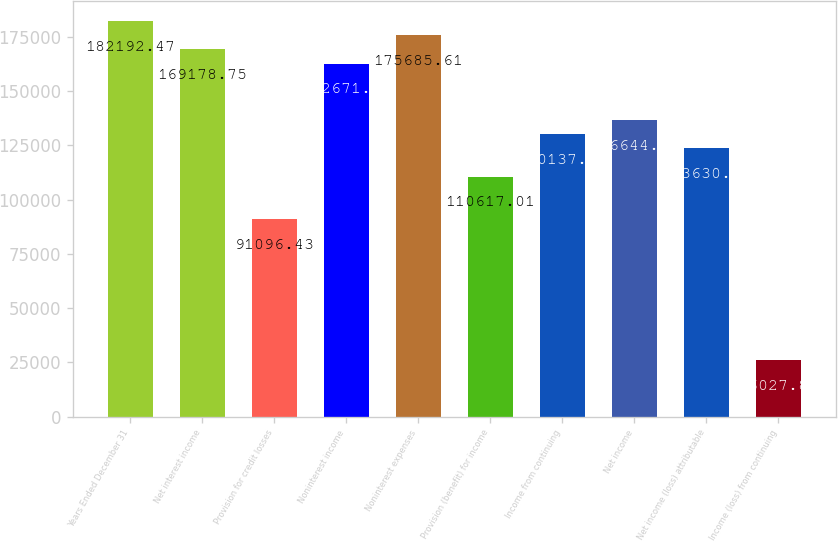<chart> <loc_0><loc_0><loc_500><loc_500><bar_chart><fcel>Years Ended December 31<fcel>Net interest income<fcel>Provision for credit losses<fcel>Noninterest income<fcel>Noninterest expenses<fcel>Provision (benefit) for income<fcel>Income from continuing<fcel>Net income<fcel>Net income (loss) attributable<fcel>Income (loss) from continuing<nl><fcel>182192<fcel>169179<fcel>91096.4<fcel>162672<fcel>175686<fcel>110617<fcel>130138<fcel>136644<fcel>123631<fcel>26027.8<nl></chart> 